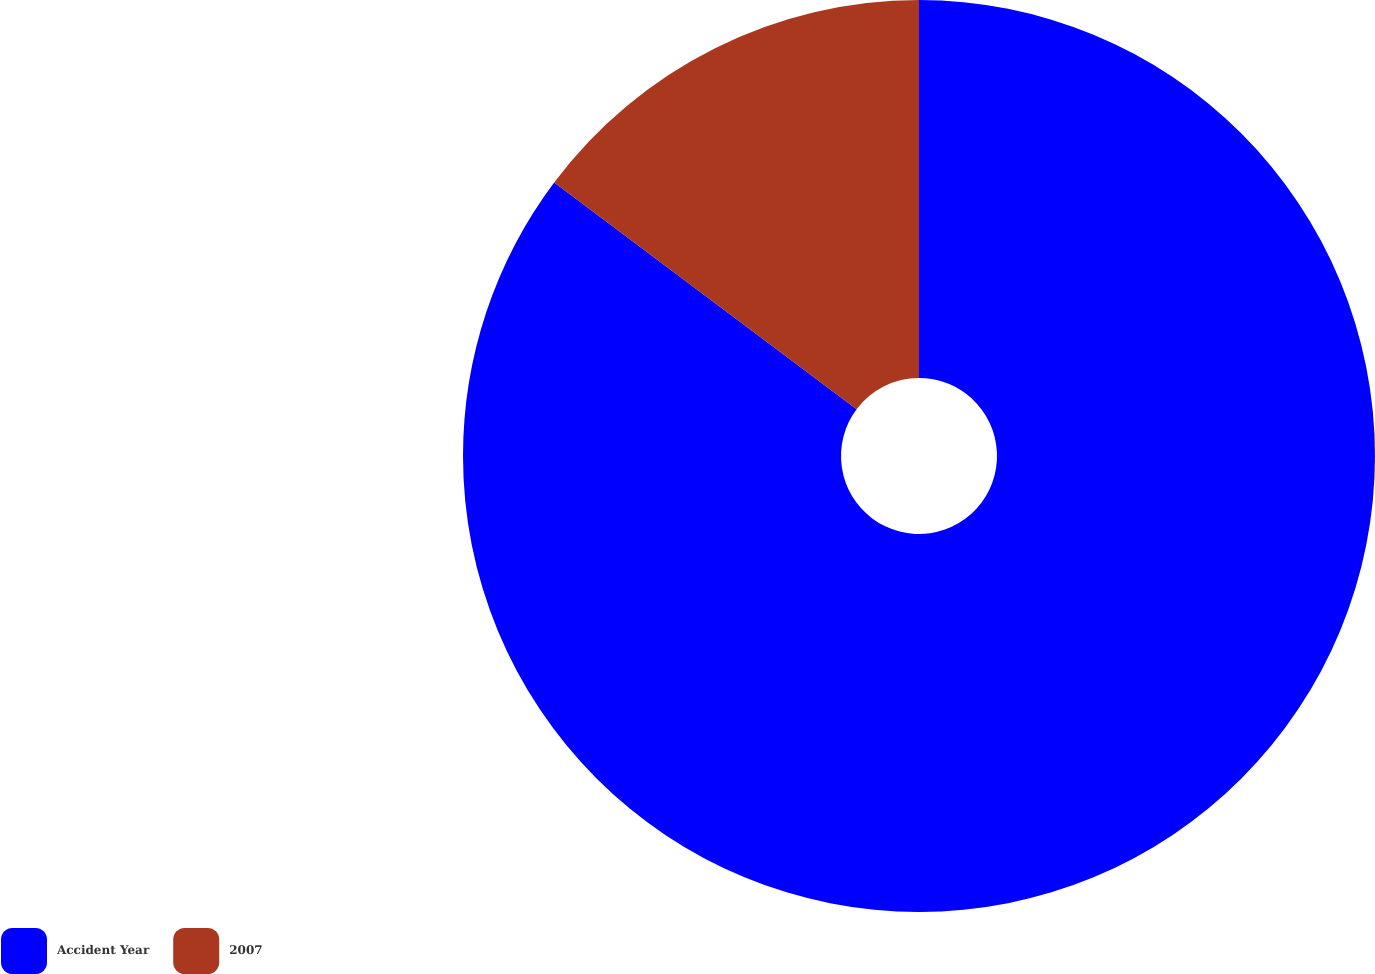<chart> <loc_0><loc_0><loc_500><loc_500><pie_chart><fcel>Accident Year<fcel>2007<nl><fcel>85.24%<fcel>14.76%<nl></chart> 